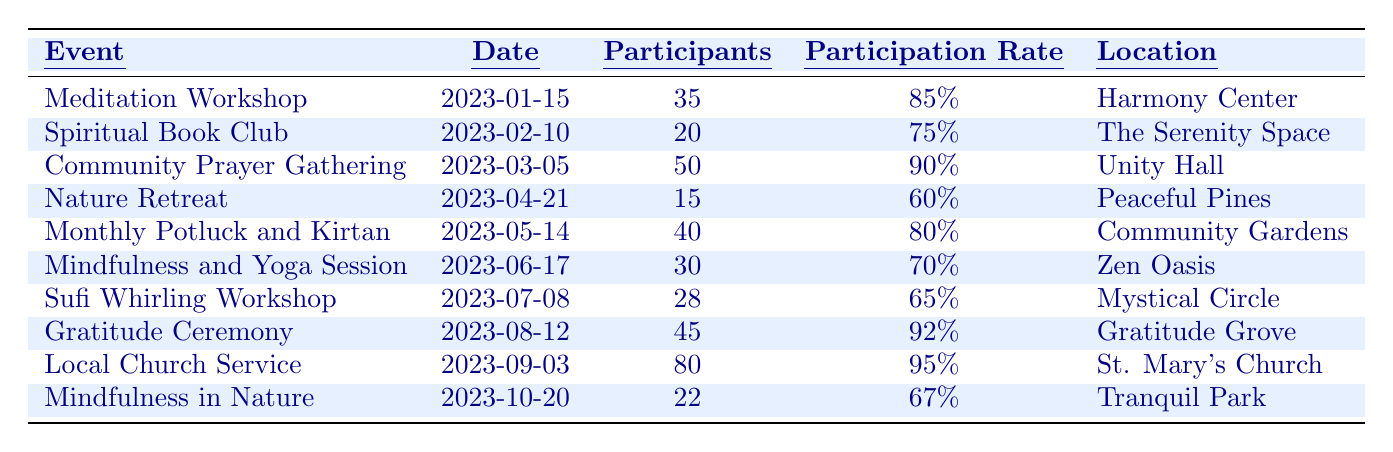What is the date of the Gratitude Ceremony? The table lists the event "Gratitude Ceremony", and the corresponding date is shown in the Date column.
Answer: August 12, 2023 How many participants attended the Community Prayer Gathering? Looking at the Community Prayer Gathering event in the table, the Participants column indicates there were 50 participants.
Answer: 50 What was the participation rate for the Monthly Potluck and Kirtan? By checking the Monthly Potluck and Kirtan entry, the Participation Rate column shows that the rate was 80%.
Answer: 80% Which event had the highest participation rate? Analyzing the Participation Rate column, I see that the Local Church Service has the highest participation rate with 95%.
Answer: Local Church Service What is the average number of participants across all events? To find the average, sum all participants: (35 + 20 + 50 + 15 + 40 + 30 + 28 + 45 + 80 + 22) =  350. There are 10 events, so the average is 350/10 = 35.
Answer: 35 Was the Participation Rate for the Nature Retreat greater than that for the Mindfulness and Yoga Session? The Participation Rate for Nature Retreat is 60%, while for Mindfulness and Yoga Session it is 70%. Since 60% is not greater than 70%, the answer is no.
Answer: No How many events had more than 40 participants? By reviewing the Participants column, I count the events with participants greater than 40: Community Prayer Gathering (50), Monthly Potluck and Kirtan (40), Gratitude Ceremony (45), and Local Church Service (80), totaling four such events.
Answer: 4 What percentage of events had a participation rate below 70%? Looking at the Participation Rate column, the events with rates under 70% are Nature Retreat (60%), Sufi Whirling Workshop (65%), and Mindfulness in Nature (67%), which accounts for 3 out of 10 events. Therefore, the percentage is (3/10) * 100 = 30%.
Answer: 30% Which event had the least number of participants? In the Participants column, I identify the event with the lowest count, which is the Nature Retreat with only 15 participants.
Answer: Nature Retreat If we only consider events in the first half of the year, what is the average participation rate? The events from January to June are the Meditation Workshop (85%), Spiritual Book Club (75%), Community Prayer Gathering (90%), Nature Retreat (60%), Monthly Potluck and Kirtan (80%), and Mindfulness and Yoga Session (70%). The sum of these rates is 85 + 75 + 90 + 60 + 80 + 70 = 450. Divided by the 6 events gives an average of 450/6 = 75%.
Answer: 75% 